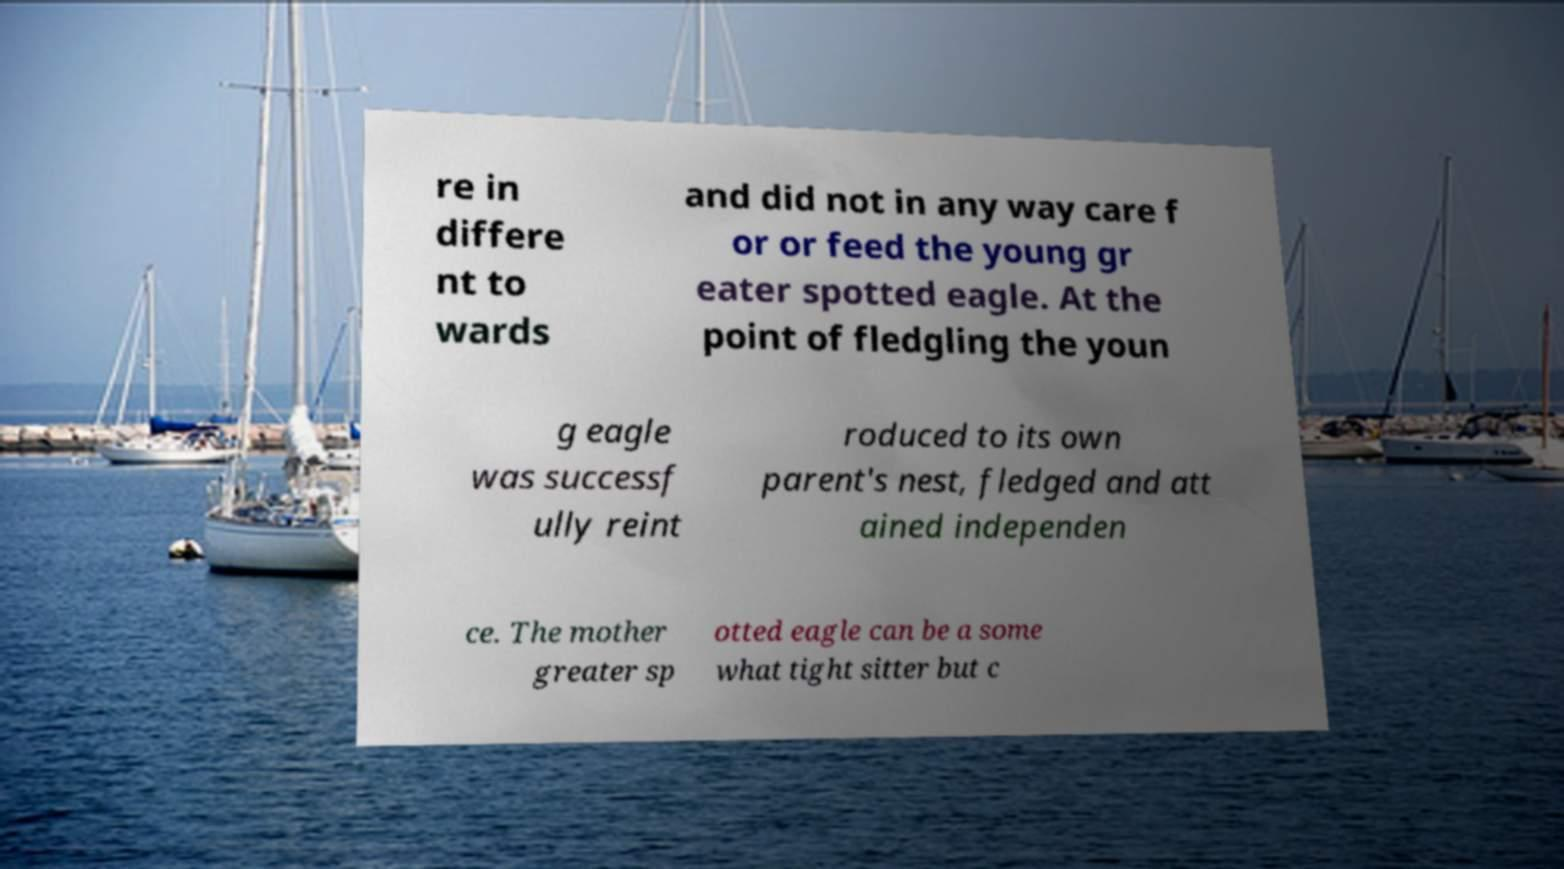Please identify and transcribe the text found in this image. re in differe nt to wards and did not in any way care f or or feed the young gr eater spotted eagle. At the point of fledgling the youn g eagle was successf ully reint roduced to its own parent's nest, fledged and att ained independen ce. The mother greater sp otted eagle can be a some what tight sitter but c 